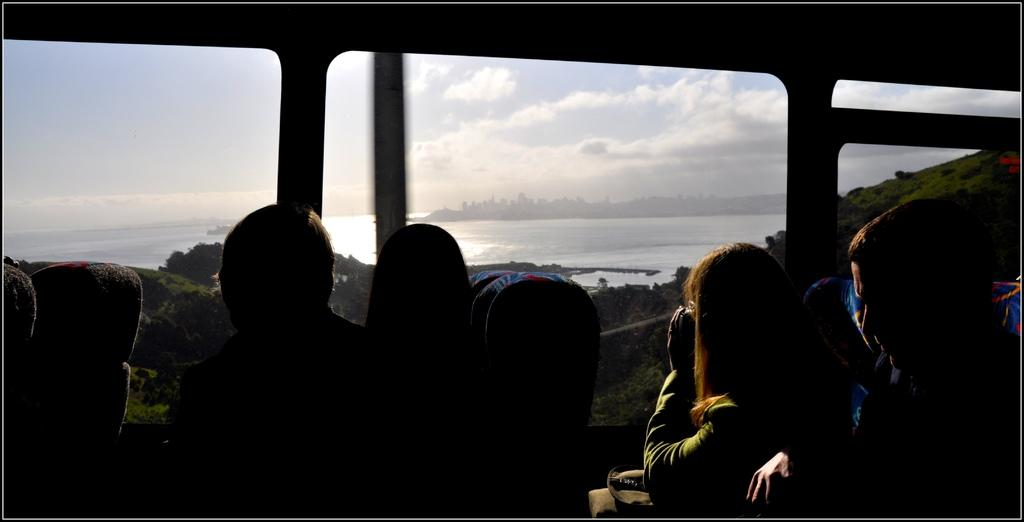What are the people in the image doing? The people in the image are seated. What can be seen outside the vehicle in the image? There is water visible in the image. What type of structures can be seen in the image? There are buildings in the image. How would you describe the weather based on the image? The sky is cloudy in the image. What is the view seen through in the image? The view is seen through the glass of a vehicle. What type of art can be seen on the lace in the image? There is no art or lace present in the image. What is the current situation of the people in the image? The image does not provide information about the current situation of the people; it only shows them seated. 